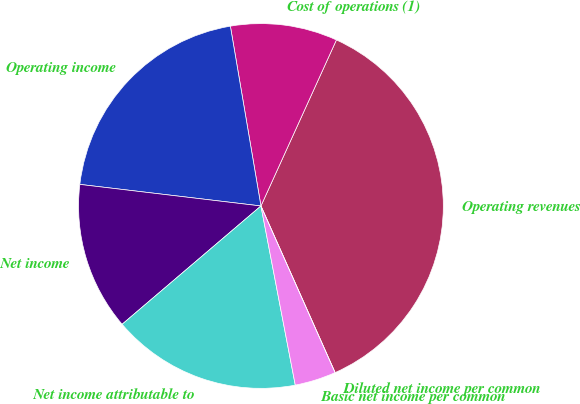Convert chart. <chart><loc_0><loc_0><loc_500><loc_500><pie_chart><fcel>Operating revenues<fcel>Cost of operations (1)<fcel>Operating income<fcel>Net income<fcel>Net income attributable to<fcel>Basic net income per common<fcel>Diluted net income per common<nl><fcel>36.54%<fcel>9.47%<fcel>20.43%<fcel>13.12%<fcel>16.78%<fcel>3.65%<fcel>0.0%<nl></chart> 